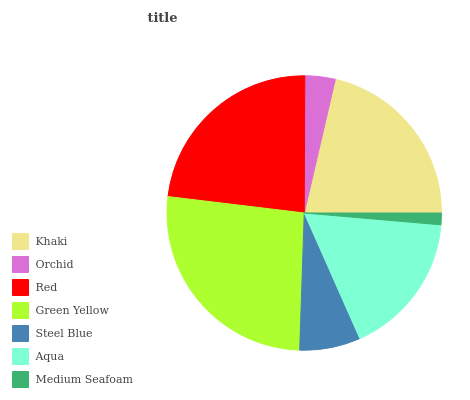Is Medium Seafoam the minimum?
Answer yes or no. Yes. Is Green Yellow the maximum?
Answer yes or no. Yes. Is Orchid the minimum?
Answer yes or no. No. Is Orchid the maximum?
Answer yes or no. No. Is Khaki greater than Orchid?
Answer yes or no. Yes. Is Orchid less than Khaki?
Answer yes or no. Yes. Is Orchid greater than Khaki?
Answer yes or no. No. Is Khaki less than Orchid?
Answer yes or no. No. Is Aqua the high median?
Answer yes or no. Yes. Is Aqua the low median?
Answer yes or no. Yes. Is Red the high median?
Answer yes or no. No. Is Steel Blue the low median?
Answer yes or no. No. 